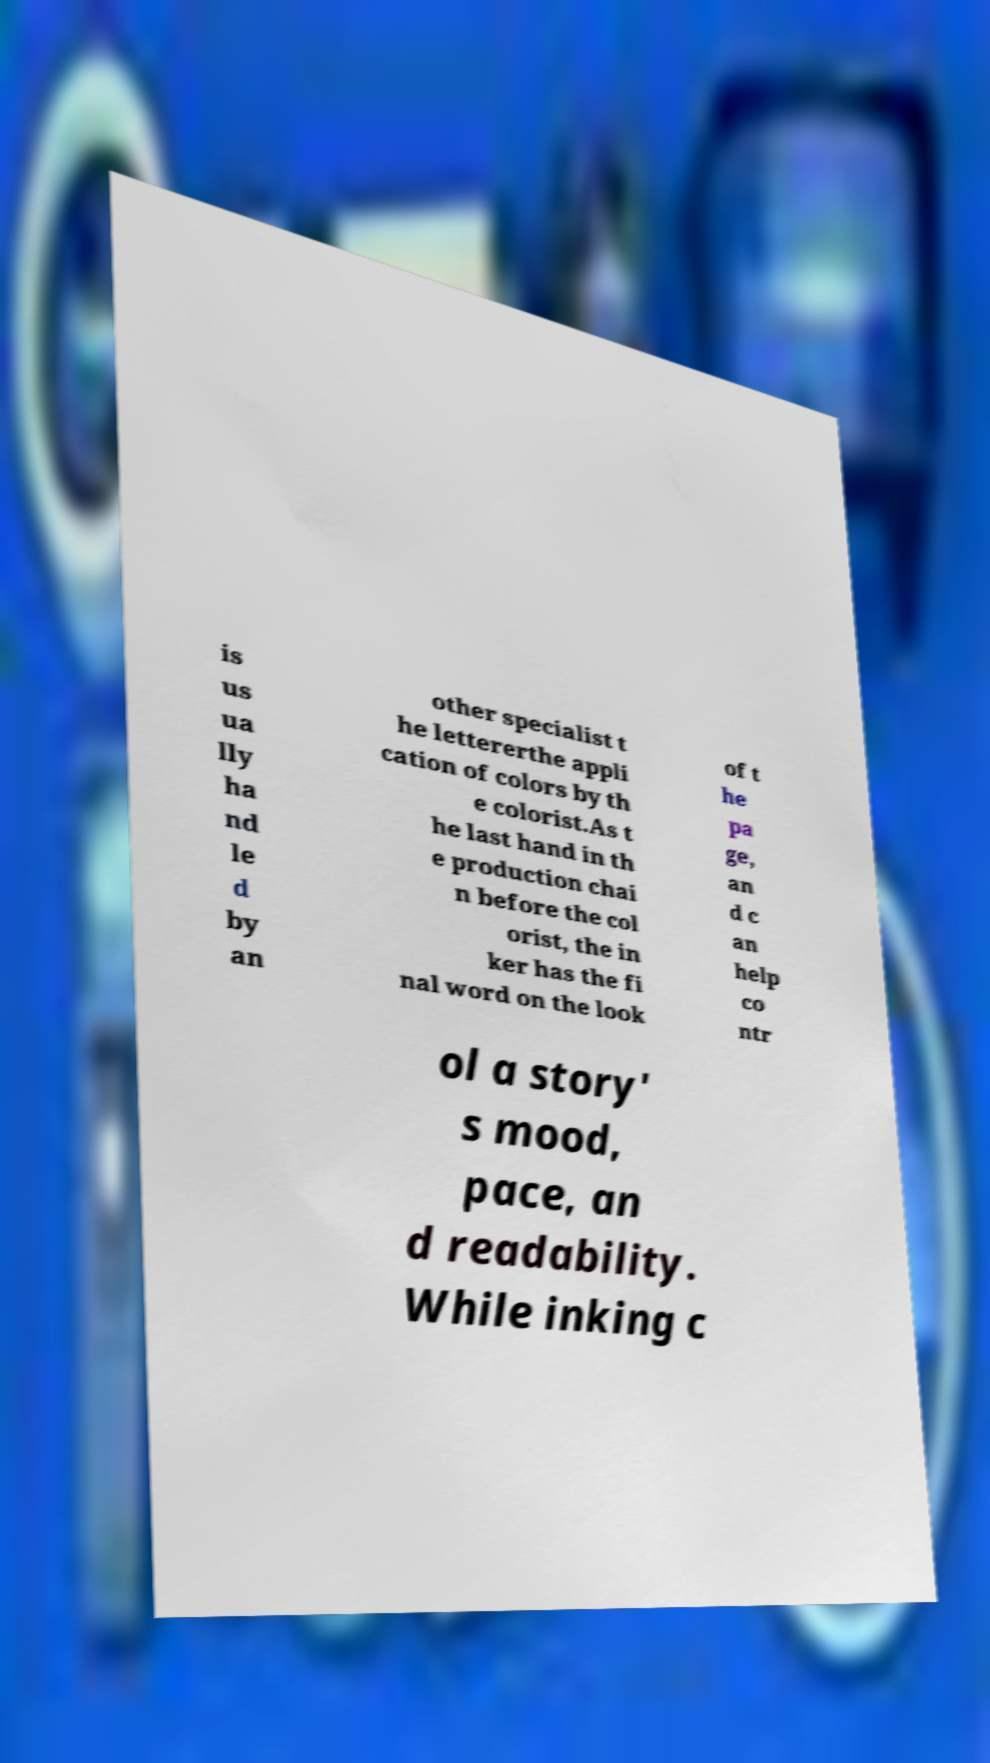For documentation purposes, I need the text within this image transcribed. Could you provide that? is us ua lly ha nd le d by an other specialist t he lettererthe appli cation of colors by th e colorist.As t he last hand in th e production chai n before the col orist, the in ker has the fi nal word on the look of t he pa ge, an d c an help co ntr ol a story' s mood, pace, an d readability. While inking c 